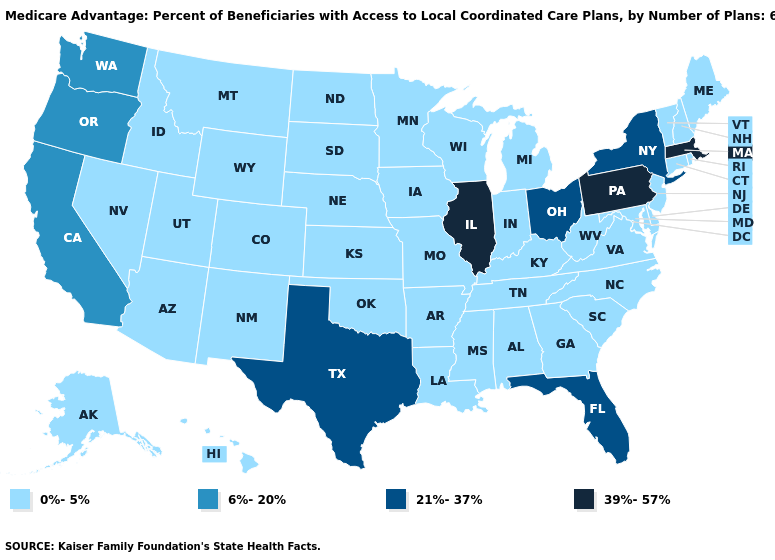What is the value of North Dakota?
Quick response, please. 0%-5%. Name the states that have a value in the range 21%-37%?
Write a very short answer. Florida, New York, Ohio, Texas. What is the lowest value in the Northeast?
Give a very brief answer. 0%-5%. What is the lowest value in the USA?
Answer briefly. 0%-5%. What is the value of New York?
Concise answer only. 21%-37%. Name the states that have a value in the range 21%-37%?
Keep it brief. Florida, New York, Ohio, Texas. Name the states that have a value in the range 0%-5%?
Be succinct. Alaska, Alabama, Arkansas, Arizona, Colorado, Connecticut, Delaware, Georgia, Hawaii, Iowa, Idaho, Indiana, Kansas, Kentucky, Louisiana, Maryland, Maine, Michigan, Minnesota, Missouri, Mississippi, Montana, North Carolina, North Dakota, Nebraska, New Hampshire, New Jersey, New Mexico, Nevada, Oklahoma, Rhode Island, South Carolina, South Dakota, Tennessee, Utah, Virginia, Vermont, Wisconsin, West Virginia, Wyoming. Is the legend a continuous bar?
Quick response, please. No. What is the value of Colorado?
Answer briefly. 0%-5%. Among the states that border California , which have the highest value?
Give a very brief answer. Oregon. What is the highest value in states that border Arizona?
Write a very short answer. 6%-20%. Name the states that have a value in the range 0%-5%?
Be succinct. Alaska, Alabama, Arkansas, Arizona, Colorado, Connecticut, Delaware, Georgia, Hawaii, Iowa, Idaho, Indiana, Kansas, Kentucky, Louisiana, Maryland, Maine, Michigan, Minnesota, Missouri, Mississippi, Montana, North Carolina, North Dakota, Nebraska, New Hampshire, New Jersey, New Mexico, Nevada, Oklahoma, Rhode Island, South Carolina, South Dakota, Tennessee, Utah, Virginia, Vermont, Wisconsin, West Virginia, Wyoming. Name the states that have a value in the range 6%-20%?
Give a very brief answer. California, Oregon, Washington. Does South Dakota have the highest value in the MidWest?
Write a very short answer. No. Does Tennessee have the lowest value in the South?
Give a very brief answer. Yes. 